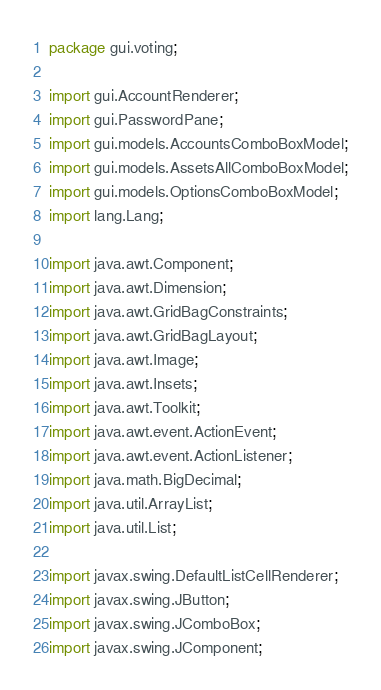<code> <loc_0><loc_0><loc_500><loc_500><_Java_>package gui.voting;

import gui.AccountRenderer;
import gui.PasswordPane;
import gui.models.AccountsComboBoxModel;
import gui.models.AssetsAllComboBoxModel;
import gui.models.OptionsComboBoxModel;
import lang.Lang;

import java.awt.Component;
import java.awt.Dimension;
import java.awt.GridBagConstraints;
import java.awt.GridBagLayout;
import java.awt.Image;
import java.awt.Insets;
import java.awt.Toolkit;
import java.awt.event.ActionEvent;
import java.awt.event.ActionListener;
import java.math.BigDecimal;
import java.util.ArrayList;
import java.util.List;

import javax.swing.DefaultListCellRenderer;
import javax.swing.JButton;
import javax.swing.JComboBox;
import javax.swing.JComponent;</code> 